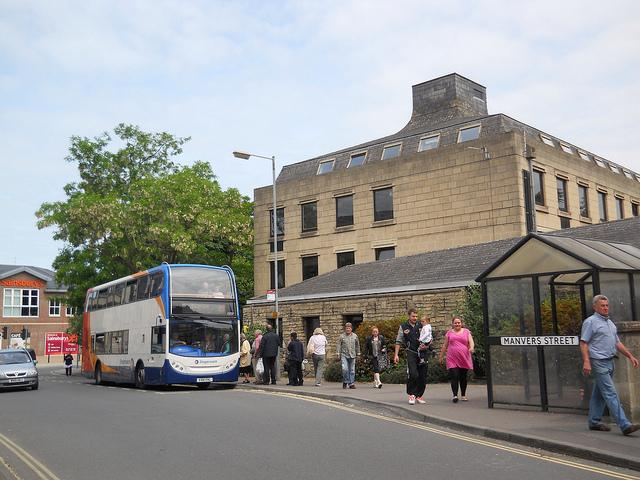When was the first bus stop installed? 1824 